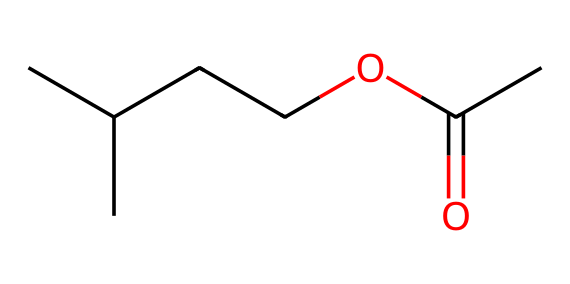What is the molecular formula of isoamyl acetate? The SMILES representation indicates the presence of 5 carbon (C) atoms, 10 hydrogen (H) atoms, and 2 oxygen (O) atoms. This leads to the molecular formula C5H10O2 for isoamyl acetate.
Answer: C5H10O2 How many double bonds are present in isoamyl acetate? By analyzing the structure, we see that there are no double bonds indicated in the SMILES representation. This means isoamyl acetate has 0 double bonds.
Answer: 0 What functional group is present in isoamyl acetate? The presence of the "OC(C)=O" portion of the SMILES indicates a carboxylate ester functional group, typical of esters. Thus, isoamyl acetate contains an ester functional group.
Answer: ester Which atoms are present in the ester functional group of isoamyl acetate? The ester functional group includes an oxygen bonded to a carbonyl (C=O) and another carbon atom. By examining the SMILES, we can find that this includes 1 carbon (C) and 2 oxygen (O) atoms.
Answer: 1 carbon, 2 oxygen What part of the molecule contributes to its banana scent? The branched carbon chain structure, specifically the isoamyl group, contributes to the characteristic banana scent of this ester. The unique structure of isoamyl derivatives is responsible for this aroma.
Answer: isoamyl group How many hydrogen atoms are bonded to the carbon chain in isoamyl acetate? Starting from the 5 carbons in the molecule and their arrangement as shown in the SMILES, the branched nature allows us to count that there are 10 hydrogen (H) atoms bonded to the carbon chain.
Answer: 10 